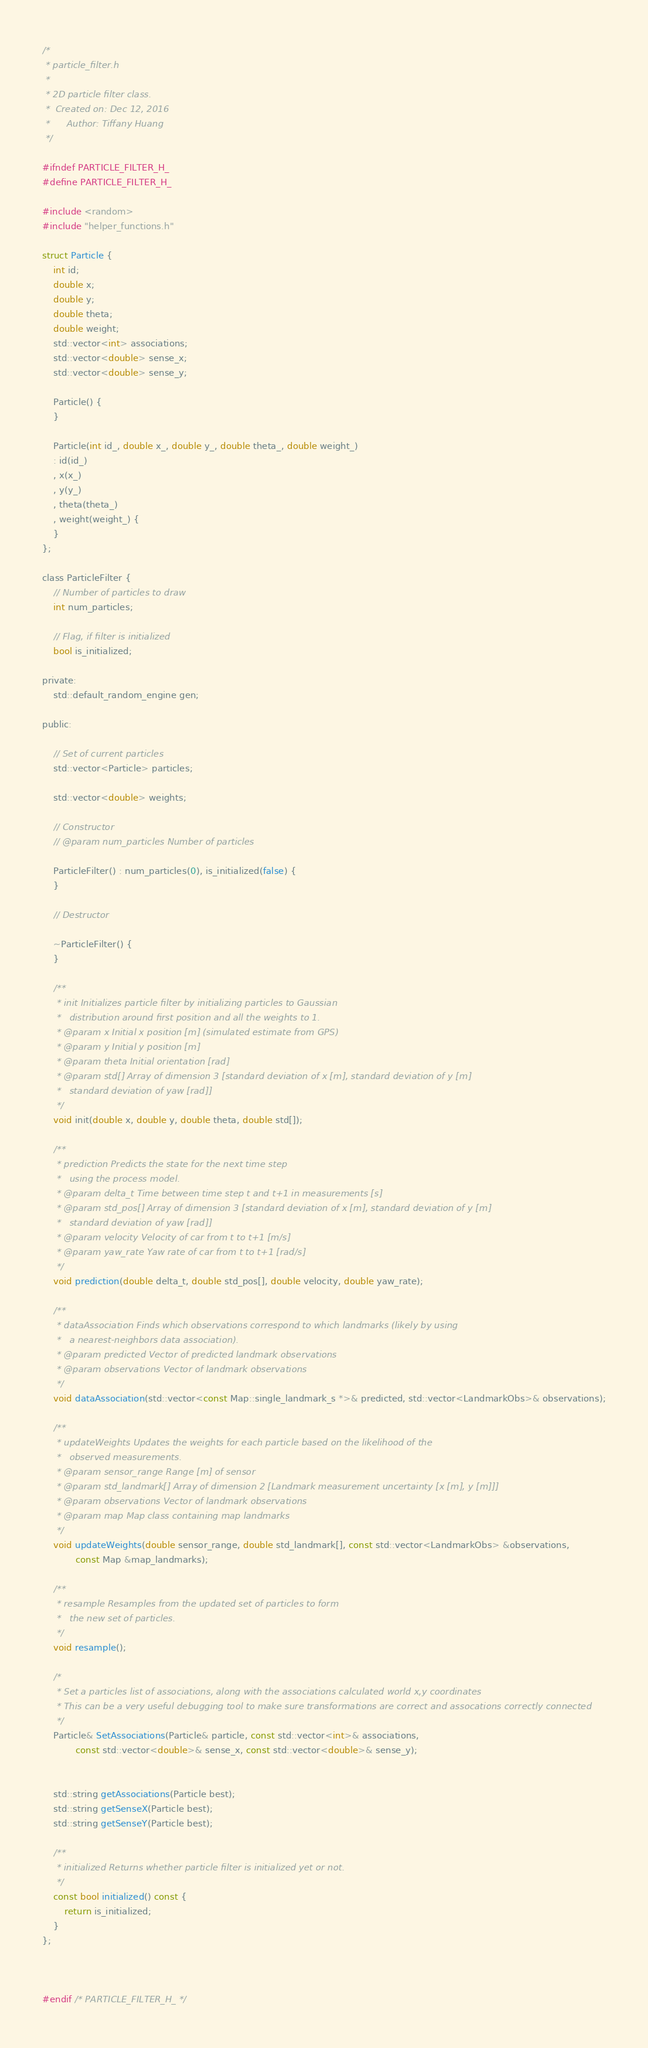Convert code to text. <code><loc_0><loc_0><loc_500><loc_500><_C_>/*
 * particle_filter.h
 *
 * 2D particle filter class.
 *  Created on: Dec 12, 2016
 *      Author: Tiffany Huang
 */

#ifndef PARTICLE_FILTER_H_
#define PARTICLE_FILTER_H_

#include <random>
#include "helper_functions.h"

struct Particle {
	int id;
	double x;
	double y;
	double theta;
	double weight;
	std::vector<int> associations;
	std::vector<double> sense_x;
	std::vector<double> sense_y;

	Particle() {
	}

	Particle(int id_, double x_, double y_, double theta_, double weight_)
	: id(id_)
	, x(x_)
	, y(y_)
	, theta(theta_)
	, weight(weight_) {
	}
};

class ParticleFilter {
	// Number of particles to draw
	int num_particles;

	// Flag, if filter is initialized
	bool is_initialized;

private:
	std::default_random_engine gen;

public:

	// Set of current particles
	std::vector<Particle> particles;
	
	std::vector<double> weights;

	// Constructor
	// @param num_particles Number of particles

	ParticleFilter() : num_particles(0), is_initialized(false) {
	}

	// Destructor

	~ParticleFilter() {
	}

	/**
	 * init Initializes particle filter by initializing particles to Gaussian
	 *   distribution around first position and all the weights to 1.
	 * @param x Initial x position [m] (simulated estimate from GPS)
	 * @param y Initial y position [m]
	 * @param theta Initial orientation [rad]
	 * @param std[] Array of dimension 3 [standard deviation of x [m], standard deviation of y [m]
	 *   standard deviation of yaw [rad]]
	 */
	void init(double x, double y, double theta, double std[]);

	/**
	 * prediction Predicts the state for the next time step
	 *   using the process model.
	 * @param delta_t Time between time step t and t+1 in measurements [s]
	 * @param std_pos[] Array of dimension 3 [standard deviation of x [m], standard deviation of y [m]
	 *   standard deviation of yaw [rad]]
	 * @param velocity Velocity of car from t to t+1 [m/s]
	 * @param yaw_rate Yaw rate of car from t to t+1 [rad/s]
	 */
	void prediction(double delta_t, double std_pos[], double velocity, double yaw_rate);

	/**
	 * dataAssociation Finds which observations correspond to which landmarks (likely by using
	 *   a nearest-neighbors data association).
	 * @param predicted Vector of predicted landmark observations
	 * @param observations Vector of landmark observations
	 */
	void dataAssociation(std::vector<const Map::single_landmark_s *>& predicted, std::vector<LandmarkObs>& observations);

	/**
	 * updateWeights Updates the weights for each particle based on the likelihood of the 
	 *   observed measurements. 
	 * @param sensor_range Range [m] of sensor
	 * @param std_landmark[] Array of dimension 2 [Landmark measurement uncertainty [x [m], y [m]]]
	 * @param observations Vector of landmark observations
	 * @param map Map class containing map landmarks
	 */
	void updateWeights(double sensor_range, double std_landmark[], const std::vector<LandmarkObs> &observations,
			const Map &map_landmarks);

	/**
	 * resample Resamples from the updated set of particles to form
	 *   the new set of particles.
	 */
	void resample();

	/*
	 * Set a particles list of associations, along with the associations calculated world x,y coordinates
	 * This can be a very useful debugging tool to make sure transformations are correct and assocations correctly connected
	 */
	Particle& SetAssociations(Particle& particle, const std::vector<int>& associations,
			const std::vector<double>& sense_x, const std::vector<double>& sense_y);


	std::string getAssociations(Particle best);
	std::string getSenseX(Particle best);
	std::string getSenseY(Particle best);

	/**
	 * initialized Returns whether particle filter is initialized yet or not.
	 */
	const bool initialized() const {
		return is_initialized;
	}
};



#endif /* PARTICLE_FILTER_H_ */
</code> 